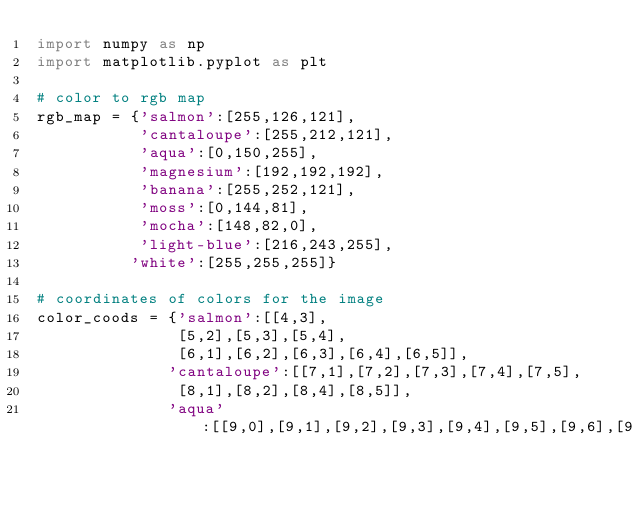<code> <loc_0><loc_0><loc_500><loc_500><_Python_>import numpy as np
import matplotlib.pyplot as plt

# color to rgb map
rgb_map = {'salmon':[255,126,121],
           'cantaloupe':[255,212,121],
           'aqua':[0,150,255],
           'magnesium':[192,192,192],
           'banana':[255,252,121],
           'moss':[0,144,81],
           'mocha':[148,82,0],
           'light-blue':[216,243,255],
          'white':[255,255,255]}

# coordinates of colors for the image
color_coods = {'salmon':[[4,3],
               [5,2],[5,3],[5,4],
               [6,1],[6,2],[6,3],[6,4],[6,5]],
              'cantaloupe':[[7,1],[7,2],[7,3],[7,4],[7,5],
               [8,1],[8,2],[8,4],[8,5]],
              'aqua':[[9,0],[9,1],[9,2],[9,3],[9,4],[9,5],[9,6],[9,7],[9,8],[9,9]],</code> 